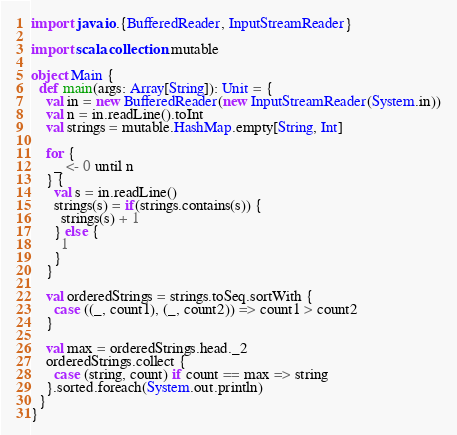Convert code to text. <code><loc_0><loc_0><loc_500><loc_500><_Scala_>import java.io.{BufferedReader, InputStreamReader}

import scala.collection.mutable

object Main {
  def main(args: Array[String]): Unit = {
    val in = new BufferedReader(new InputStreamReader(System.in))
    val n = in.readLine().toInt
    val strings = mutable.HashMap.empty[String, Int]

    for {
      _ <- 0 until n
    } {
      val s = in.readLine()
      strings(s) = if(strings.contains(s)) {
        strings(s) + 1
      } else {
        1
      }
    }

    val orderedStrings = strings.toSeq.sortWith {
      case ((_, count1), (_, count2)) => count1 > count2
    }

    val max = orderedStrings.head._2
    orderedStrings.collect {
      case (string, count) if count == max => string
    }.sorted.foreach(System.out.println)
  }
}
</code> 